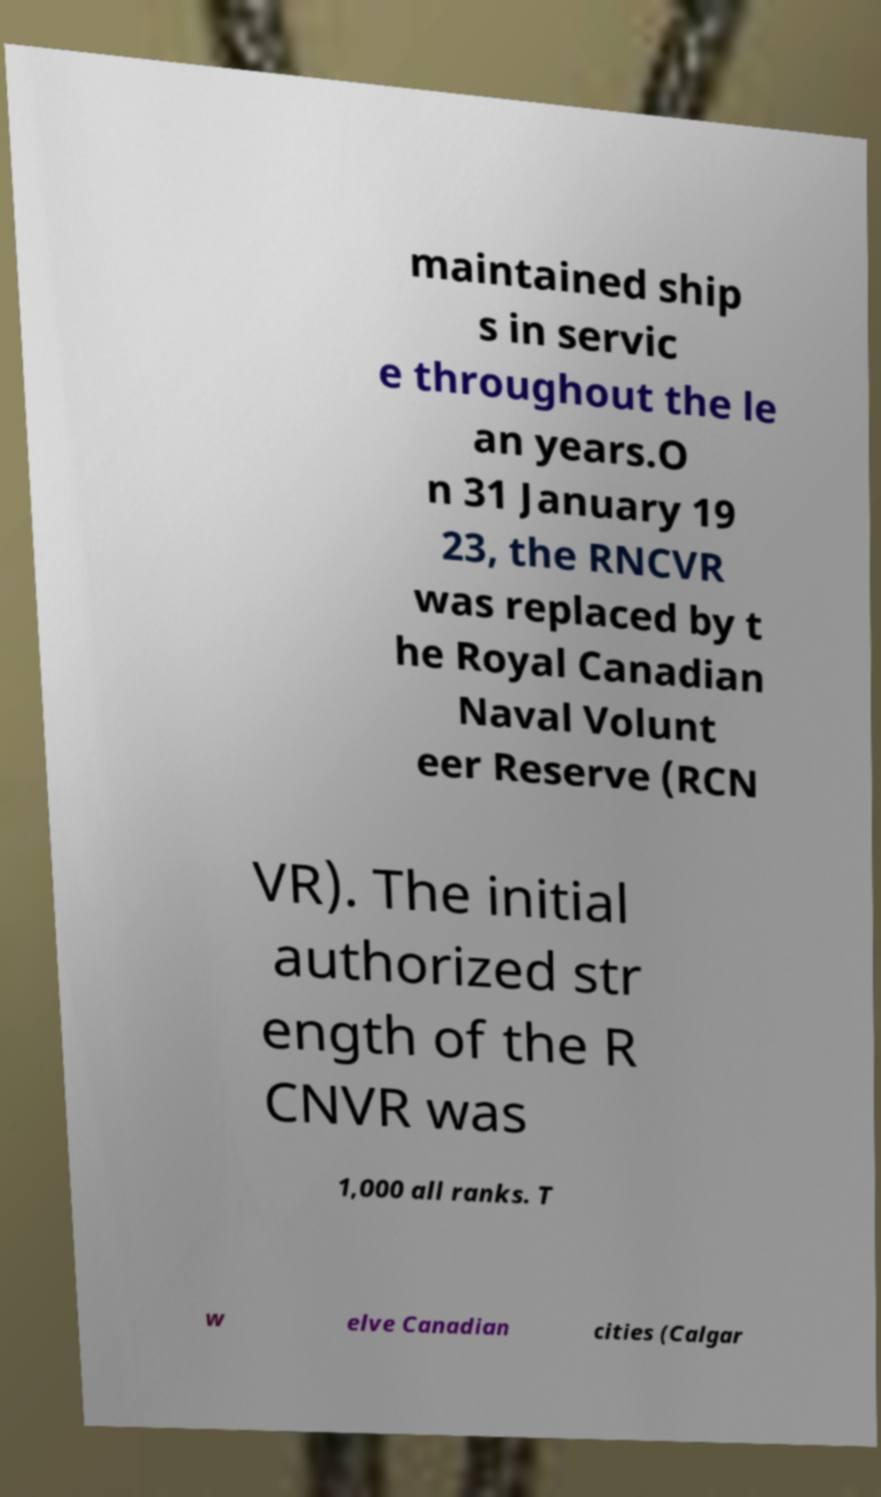What messages or text are displayed in this image? I need them in a readable, typed format. maintained ship s in servic e throughout the le an years.O n 31 January 19 23, the RNCVR was replaced by t he Royal Canadian Naval Volunt eer Reserve (RCN VR). The initial authorized str ength of the R CNVR was 1,000 all ranks. T w elve Canadian cities (Calgar 